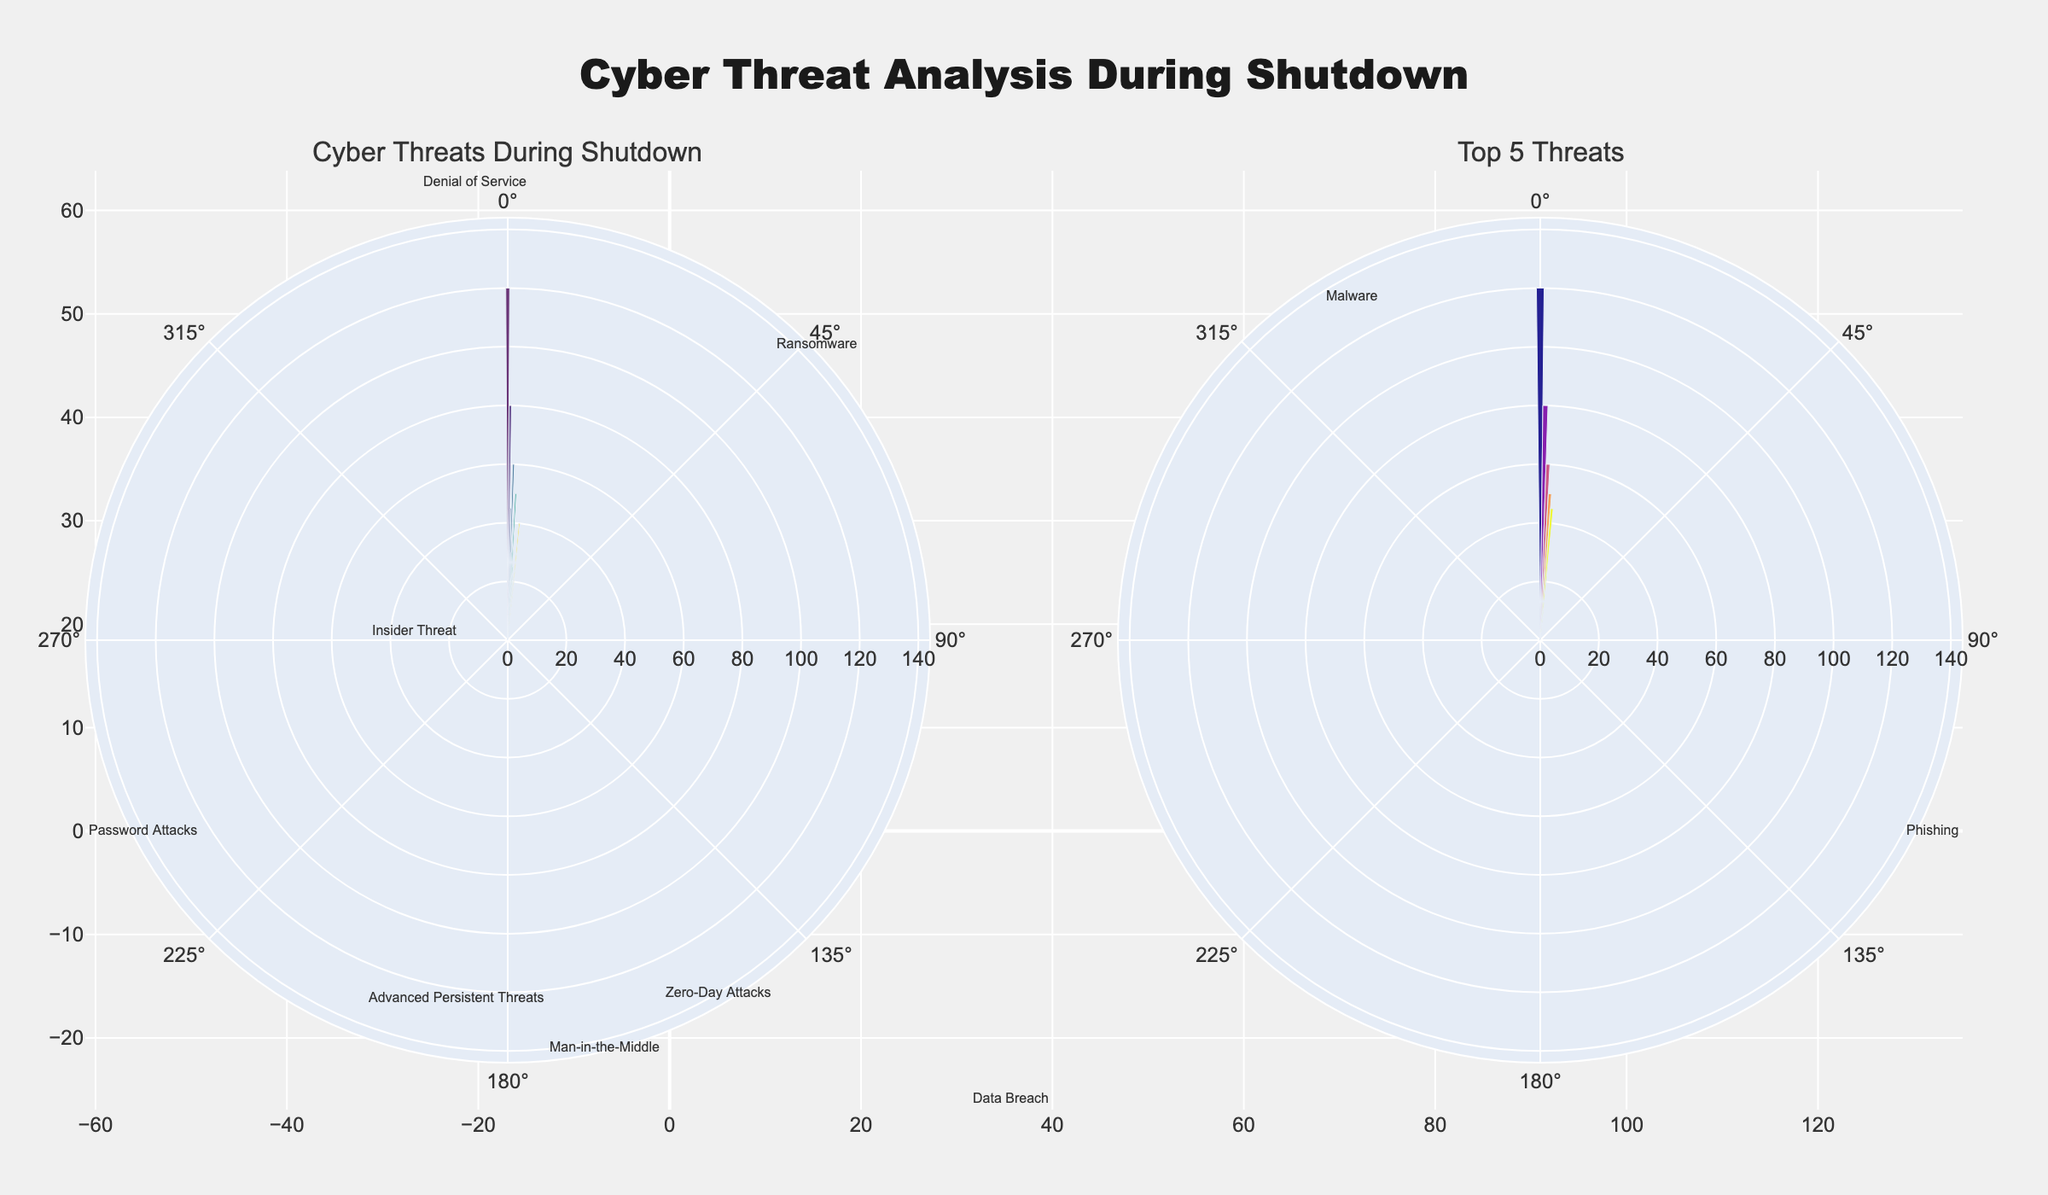What's the most frequent cyber threat during shutdown periods? From the titles and the visual cues in the rose chart, 'Phishing' has the highest bar length. It shows a higher frequency than the other threats.
Answer: Phishing What's the least frequent cyber threat during shutdown periods? The visual analysis of the rose chart shows 'Zero-Day Attacks' with the shortest bar length, making it the least frequent threat.
Answer: Zero-Day Attacks Which cyber threat ranks as the second most frequent? Observing the bar lengths, 'Malware' is the second highest, right after 'Phishing'.
Answer: Malware Compare the frequency between 'Data Breach' and 'Denial of Service' threats during shutdown periods. Which is more frequent? By comparing the bar lengths, it's clear that 'Denial of Service' (60) has a longer bar than 'Data Breach' (40).
Answer: Denial of Service What are the top 5 most frequent cyber threats during shutdown periods? The top 5 threats, observed from the second subplot titled 'Top 5 Threats', with the longest bars are: Phishing (120), Malware (80), Denial of Service (60), Password Attacks (50), and Ransomware (45).
Answer: Phishing, Malware, Denial of Service, Password Attacks, Ransomware What's the combined frequency of the top 3 cyber threats during shutdown periods? Summing the highest three frequencies in the top 5 threats subplot: Phishing (120), Malware (80), and Denial of Service (60) gives: 120 + 80 + 60 = 260.
Answer: 260 How does the frequency of 'Insider Threat' compare to 'Password Attacks'? Comparing their bar lengths, 'Password Attacks' (50) has a higher frequency than 'Insider Threat' (30).
Answer: Password Attacks What is the midpoint frequency value among all 10 cyber threats? Sorting the frequencies: (15, 20, 25, 30, 40, 45, 50, 60, 80, 120) and finding the midpoint, between 45 and 50, the median is (45 + 50) / 2 = 47.5.
Answer: 47.5 Is 'Man-in-the-Middle' more or less frequent than 'Advanced Persistent Threats'? The comparison of bar lengths shows that 'Man-in-the-Middle' (20) is less frequent than 'Advanced Persistent Threats' (25).
Answer: Less frequent What proportion of incidents are caused by 'Ransomware' relative to 'Phishing'? The relative frequency is calculated by dividing Ransomware's frequency (45) by Phishing's frequency (120): 45 / 120 = 0.375.
Answer: 0.375 